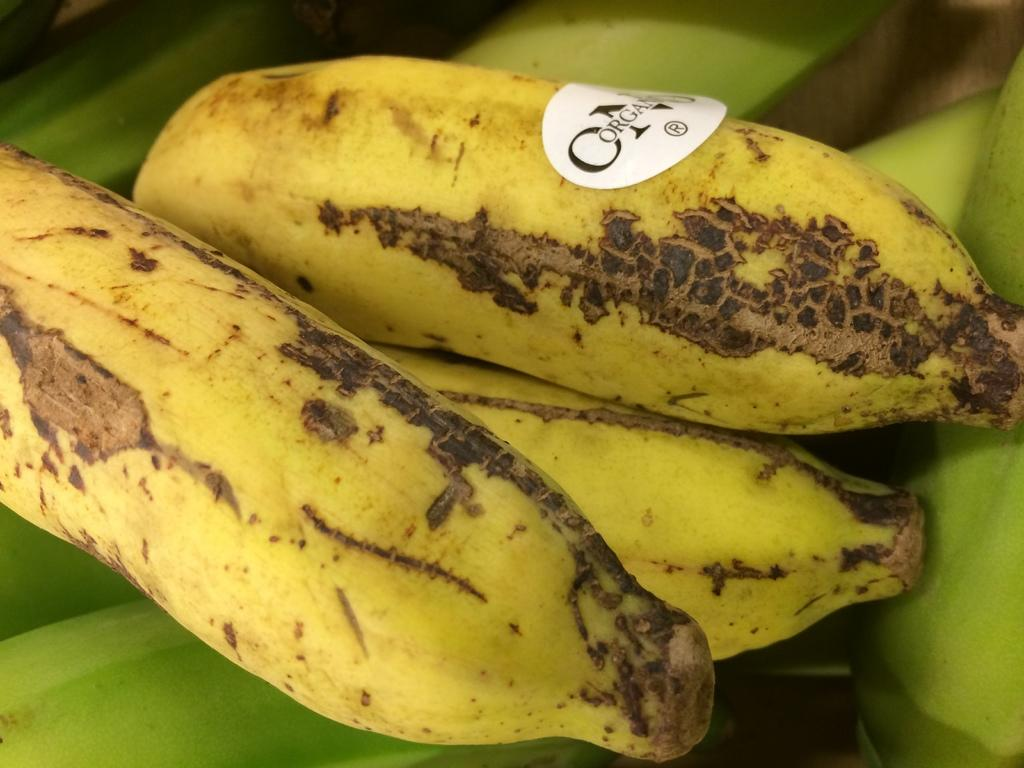What type of fruit is present in the image? There are bananas in the image. Are there any additional features on the bananas? Yes, there is a sticker is on one of the bananas. What can be found on the sticker? The sticker has text on it. What type of yam is being treated at the hospital in the image? There is no yam or hospital present in the image; it features bananas with a sticker on one of them. How many times has the banana been folded in the image? Bananas do not fold, so this question cannot be answered based on the image. 